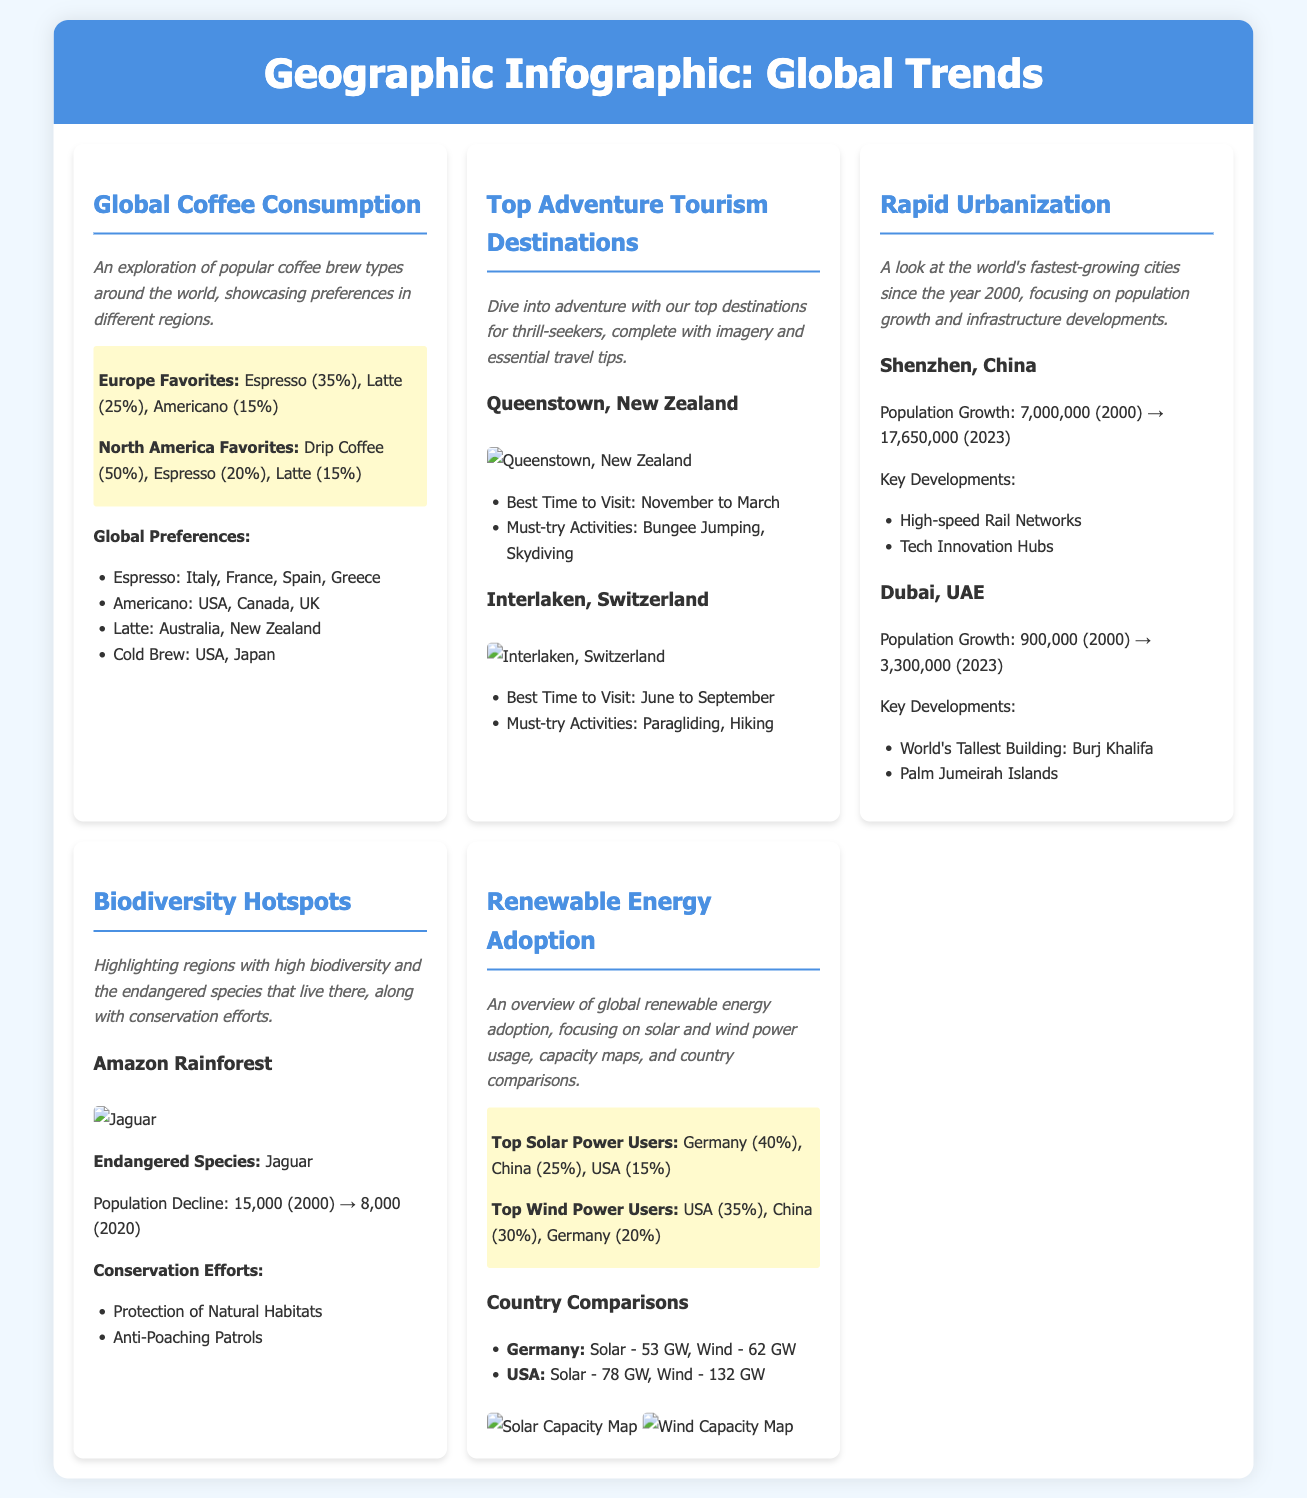What is the favorite coffee brew type in Europe? Europe’s favorite coffee brew types are Espresso (35%) and Latte (25%).
Answer: Espresso What are two must-try activities in Queenstown, New Zealand? The must-try activities in Queenstown are Bungee Jumping and Skydiving.
Answer: Bungee Jumping, Skydiving What was Shenzhen's population in the year 2000? Shenzhen had a population of 7,000,000 in the year 2000.
Answer: 7,000,000 How much did the Jaguar population decline from 2000 to 2020? The Jaguar population declined from 15,000 in 2000 to 8,000 in 2020.
Answer: 7,000 Which country is the top user of wind power? The USA is the top user of wind power, utilizing 35%.
Answer: USA What is the best time to visit Interlaken, Switzerland? The best time to visit Interlaken is June to September.
Answer: June to September How many gigawatts of solar power does Germany have? Germany has 53 gigawatts of solar power capacity.
Answer: 53 GW What type of infographic is this document? This document is a geographic infographic focusing on global trends.
Answer: Geographic infographic What is a key development in Dubai since 2000? A key development in Dubai is the world's tallest building, Burj Khalifa.
Answer: Burj Khalifa 